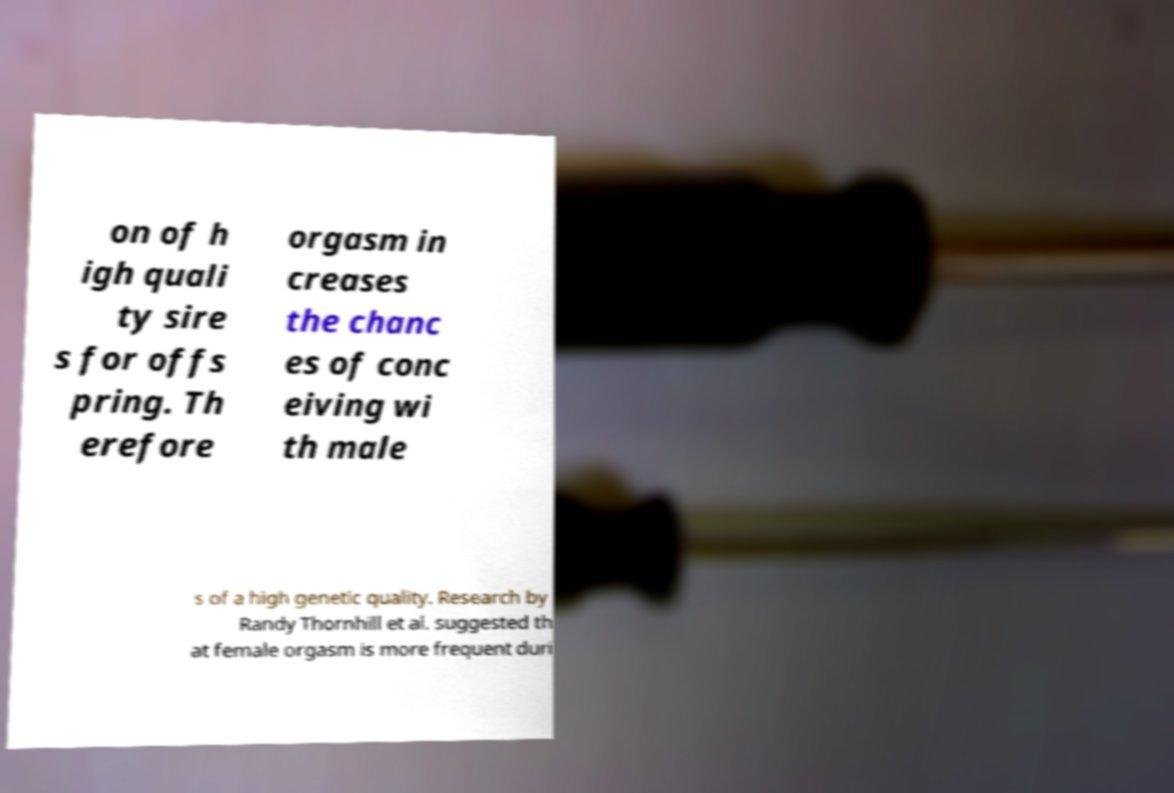I need the written content from this picture converted into text. Can you do that? on of h igh quali ty sire s for offs pring. Th erefore orgasm in creases the chanc es of conc eiving wi th male s of a high genetic quality. Research by Randy Thornhill et al. suggested th at female orgasm is more frequent duri 